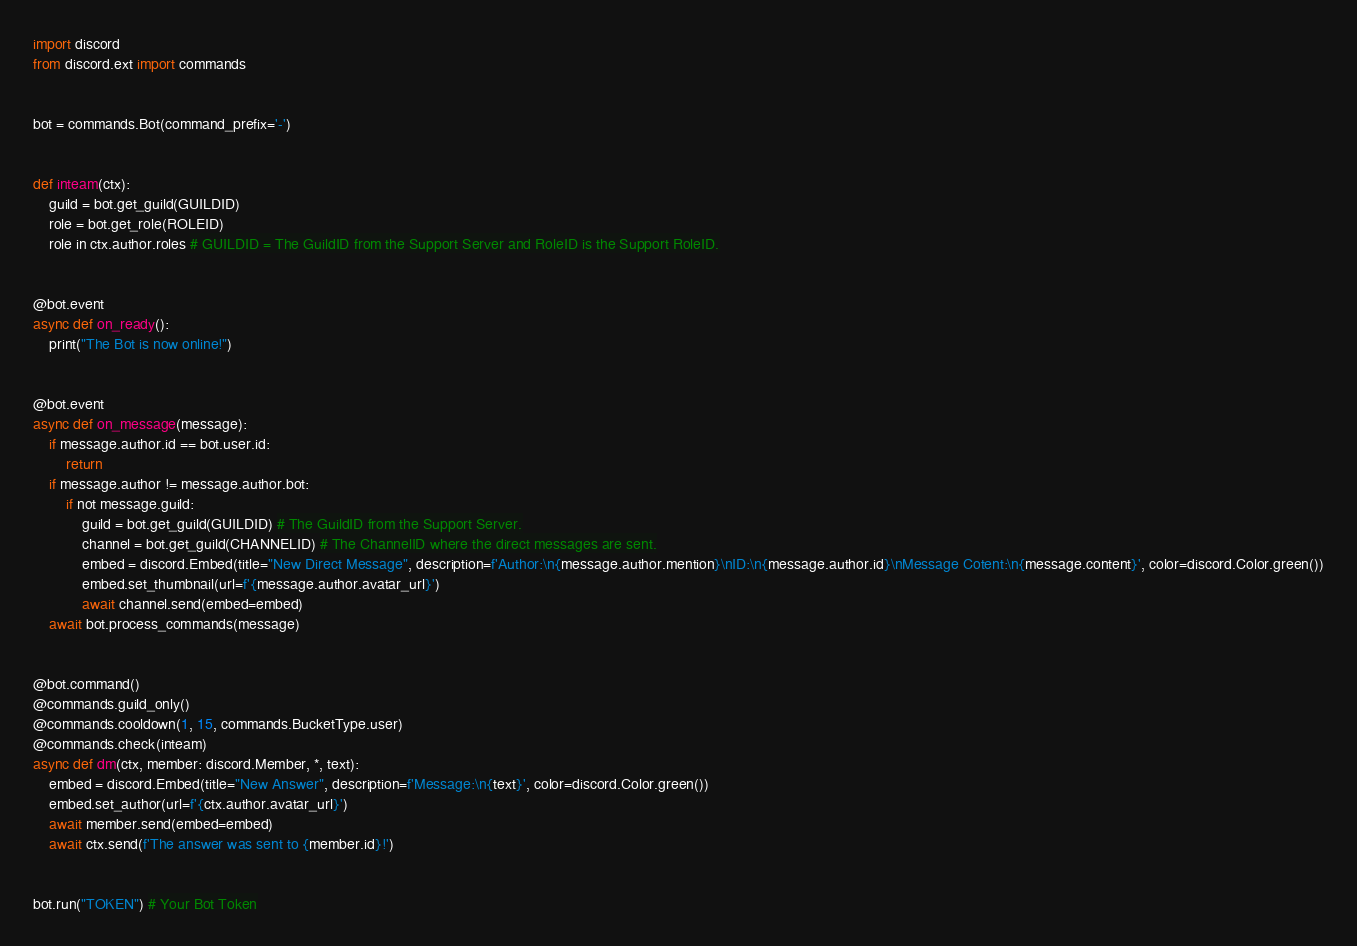<code> <loc_0><loc_0><loc_500><loc_500><_Python_>import discord
from discord.ext import commands


bot = commands.Bot(command_prefix='-')


def inteam(ctx):
    guild = bot.get_guild(GUILDID)
    role = bot.get_role(ROLEID)
    role in ctx.author.roles # GUILDID = The GuildID from the Support Server and RoleID is the Support RoleID.


@bot.event
async def on_ready():
    print("The Bot is now online!")


@bot.event
async def on_message(message):
    if message.author.id == bot.user.id:
        return
    if message.author != message.author.bot:
        if not message.guild:
            guild = bot.get_guild(GUILDID) # The GuildID from the Support Server.
            channel = bot.get_guild(CHANNELID) # The ChannelID where the direct messages are sent.
            embed = discord.Embed(title="New Direct Message", description=f'Author:\n{message.author.mention}\nID:\n{message.author.id}\nMessage Cotent:\n{message.content}', color=discord.Color.green())
            embed.set_thumbnail(url=f'{message.author.avatar_url}')
            await channel.send(embed=embed)
    await bot.process_commands(message)


@bot.command()
@commands.guild_only()
@commands.cooldown(1, 15, commands.BucketType.user)
@commands.check(inteam)
async def dm(ctx, member: discord.Member, *, text):
    embed = discord.Embed(title="New Answer", description=f'Message:\n{text}', color=discord.Color.green())
    embed.set_author(url=f'{ctx.author.avatar_url}')
    await member.send(embed=embed)
    await ctx.send(f'The answer was sent to {member.id}!')


bot.run("TOKEN") # Your Bot Token</code> 